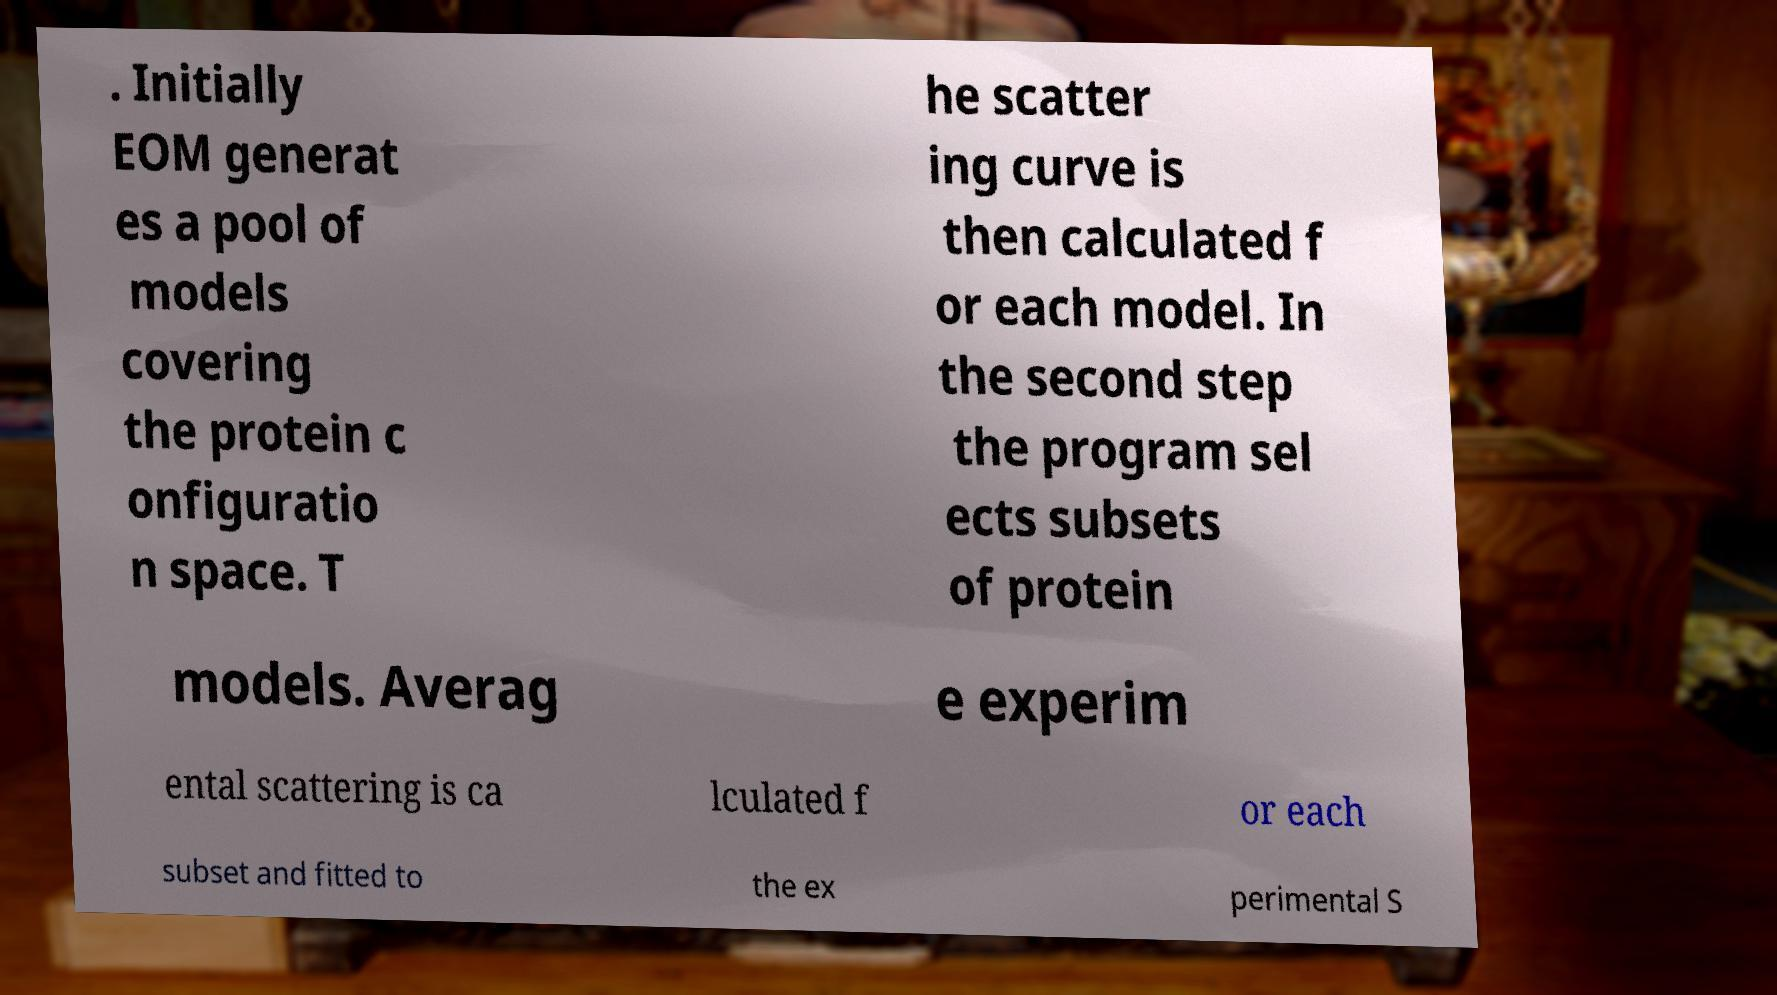Can you accurately transcribe the text from the provided image for me? . Initially EOM generat es a pool of models covering the protein c onfiguratio n space. T he scatter ing curve is then calculated f or each model. In the second step the program sel ects subsets of protein models. Averag e experim ental scattering is ca lculated f or each subset and fitted to the ex perimental S 